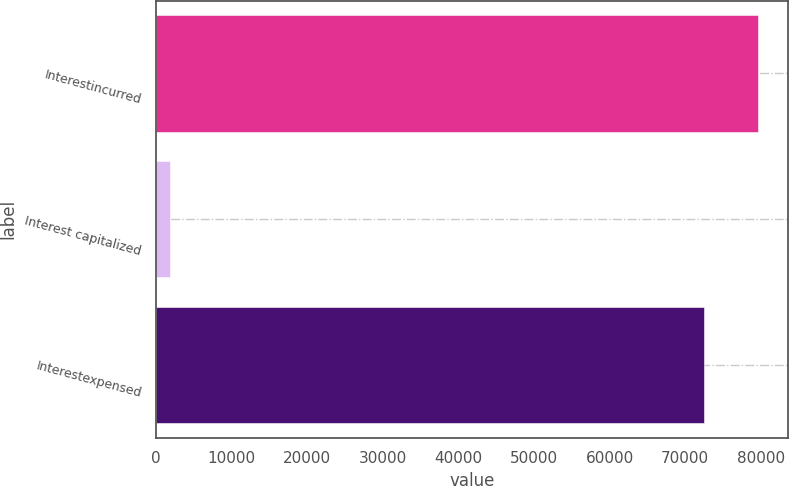Convert chart. <chart><loc_0><loc_0><loc_500><loc_500><bar_chart><fcel>Interestincurred<fcel>Interest capitalized<fcel>Interestexpensed<nl><fcel>79685.1<fcel>1900<fcel>72441<nl></chart> 